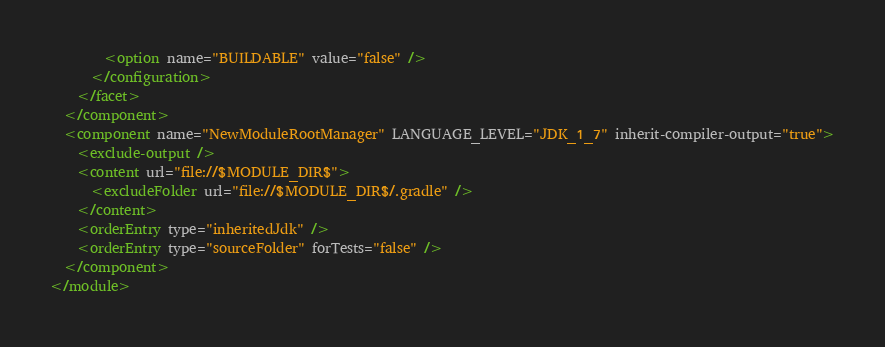<code> <loc_0><loc_0><loc_500><loc_500><_XML_>        <option name="BUILDABLE" value="false" />
      </configuration>
    </facet>
  </component>
  <component name="NewModuleRootManager" LANGUAGE_LEVEL="JDK_1_7" inherit-compiler-output="true">
    <exclude-output />
    <content url="file://$MODULE_DIR$">
      <excludeFolder url="file://$MODULE_DIR$/.gradle" />
    </content>
    <orderEntry type="inheritedJdk" />
    <orderEntry type="sourceFolder" forTests="false" />
  </component>
</module></code> 